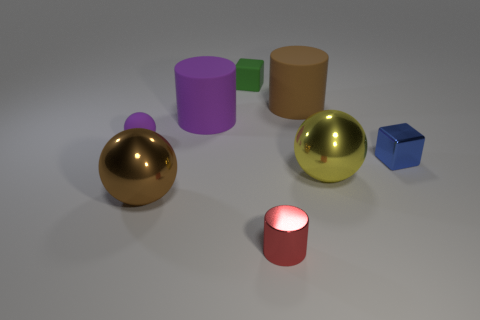Subtract all large brown metal spheres. How many spheres are left? 2 Add 2 small rubber blocks. How many objects exist? 10 Subtract all brown balls. How many balls are left? 2 Subtract 1 blue cubes. How many objects are left? 7 Subtract all balls. How many objects are left? 5 Subtract 1 balls. How many balls are left? 2 Subtract all green blocks. Subtract all purple cylinders. How many blocks are left? 1 Subtract all small green blocks. Subtract all tiny blue blocks. How many objects are left? 6 Add 7 brown rubber things. How many brown rubber things are left? 8 Add 7 purple things. How many purple things exist? 9 